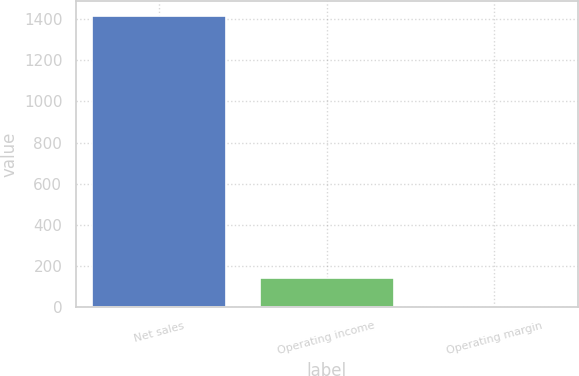Convert chart to OTSL. <chart><loc_0><loc_0><loc_500><loc_500><bar_chart><fcel>Net sales<fcel>Operating income<fcel>Operating margin<nl><fcel>1415<fcel>143.66<fcel>2.4<nl></chart> 